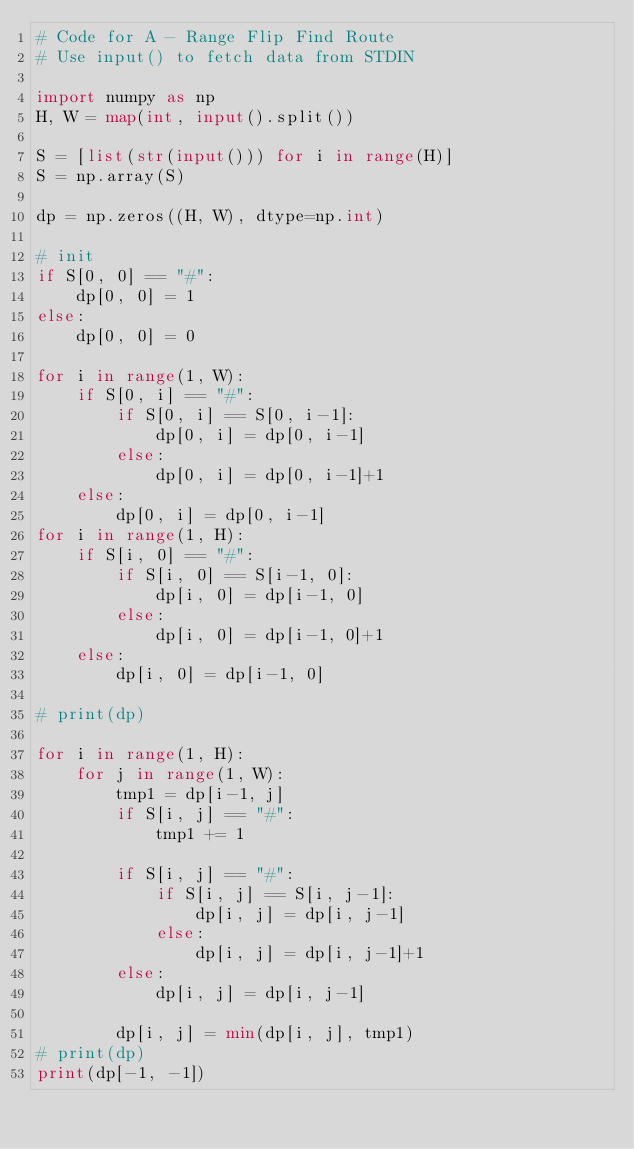Convert code to text. <code><loc_0><loc_0><loc_500><loc_500><_Python_># Code for A - Range Flip Find Route
# Use input() to fetch data from STDIN

import numpy as np
H, W = map(int, input().split())

S = [list(str(input())) for i in range(H)]
S = np.array(S)

dp = np.zeros((H, W), dtype=np.int)

# init
if S[0, 0] == "#":
    dp[0, 0] = 1
else:
    dp[0, 0] = 0

for i in range(1, W):
    if S[0, i] == "#":
        if S[0, i] == S[0, i-1]:
            dp[0, i] = dp[0, i-1]
        else:
            dp[0, i] = dp[0, i-1]+1
    else:
        dp[0, i] = dp[0, i-1]
for i in range(1, H):
    if S[i, 0] == "#":
        if S[i, 0] == S[i-1, 0]:
            dp[i, 0] = dp[i-1, 0]
        else:
            dp[i, 0] = dp[i-1, 0]+1
    else:
        dp[i, 0] = dp[i-1, 0]

# print(dp)

for i in range(1, H):
    for j in range(1, W):
        tmp1 = dp[i-1, j]
        if S[i, j] == "#":
            tmp1 += 1

        if S[i, j] == "#":
            if S[i, j] == S[i, j-1]:
                dp[i, j] = dp[i, j-1]
            else:
                dp[i, j] = dp[i, j-1]+1
        else:
            dp[i, j] = dp[i, j-1]

        dp[i, j] = min(dp[i, j], tmp1)
# print(dp)
print(dp[-1, -1])
</code> 